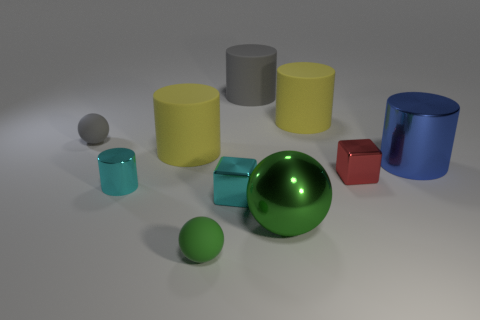How many metal objects are either tiny red things or gray spheres?
Provide a short and direct response. 1. Is there any other thing that has the same size as the green rubber sphere?
Provide a short and direct response. Yes. What is the shape of the rubber object in front of the ball to the right of the green matte object?
Your response must be concise. Sphere. Are the small ball that is behind the small red object and the green ball on the left side of the big gray cylinder made of the same material?
Provide a succinct answer. Yes. How many green spheres are to the left of the tiny cyan metallic block left of the large metal cylinder?
Make the answer very short. 1. There is a large rubber thing that is left of the gray cylinder; is it the same shape as the gray object that is behind the small gray rubber sphere?
Your answer should be compact. Yes. There is a cylinder that is both in front of the gray ball and right of the big ball; what is its size?
Offer a very short reply. Large. There is another small metallic thing that is the same shape as the red metal object; what is its color?
Give a very brief answer. Cyan. What color is the tiny matte ball behind the big metal thing behind the small cyan metal block?
Provide a short and direct response. Gray. The red thing is what shape?
Ensure brevity in your answer.  Cube. 